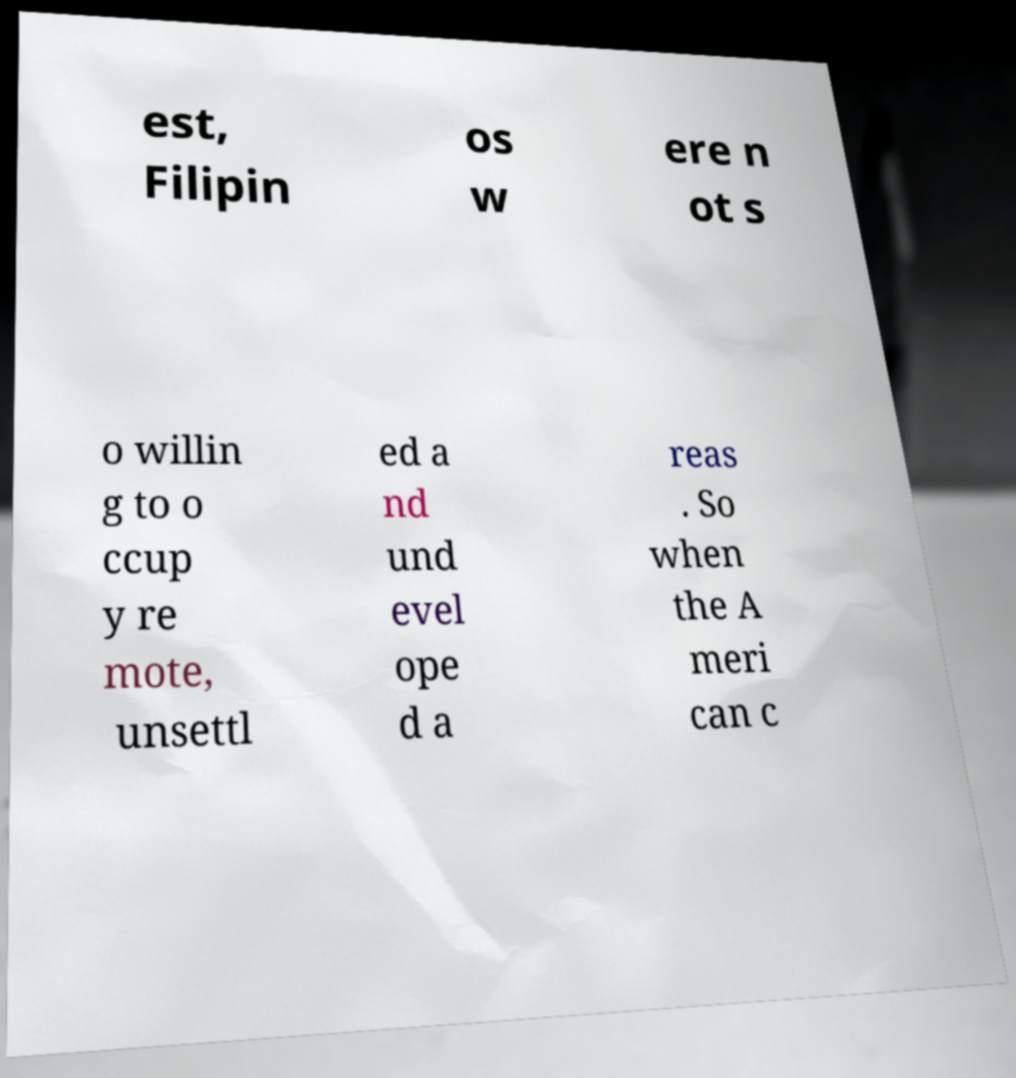For documentation purposes, I need the text within this image transcribed. Could you provide that? est, Filipin os w ere n ot s o willin g to o ccup y re mote, unsettl ed a nd und evel ope d a reas . So when the A meri can c 